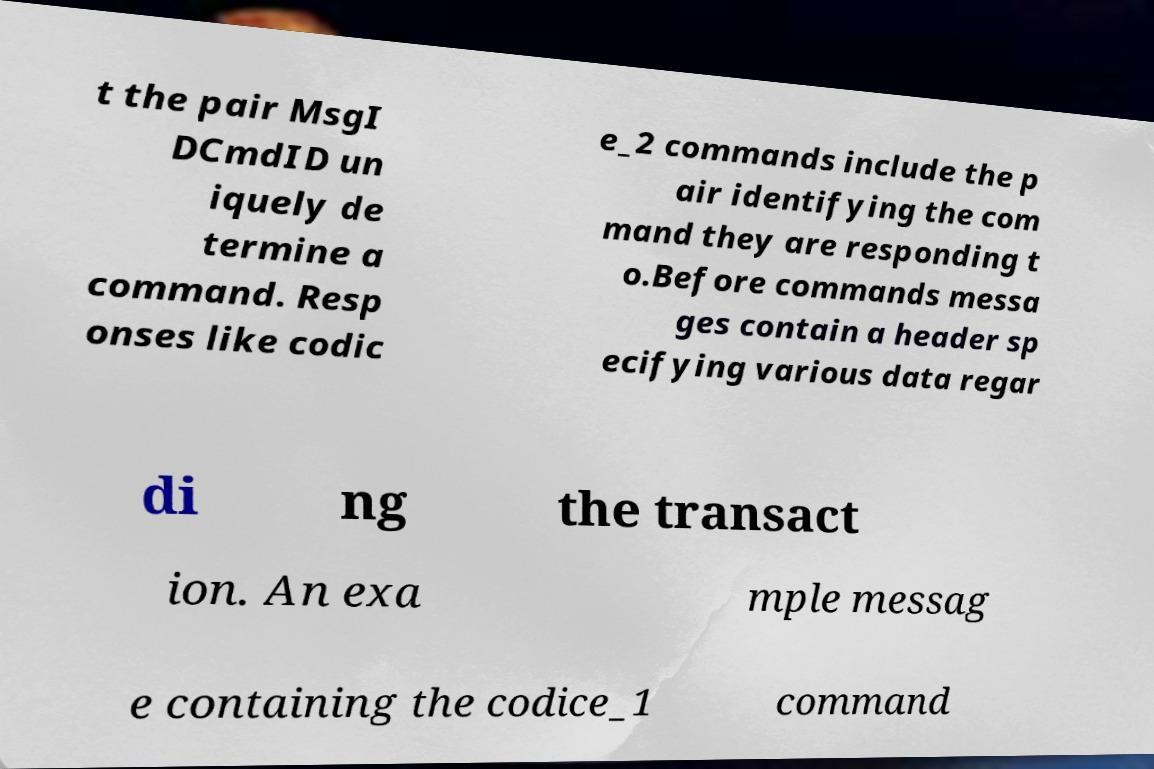I need the written content from this picture converted into text. Can you do that? t the pair MsgI DCmdID un iquely de termine a command. Resp onses like codic e_2 commands include the p air identifying the com mand they are responding t o.Before commands messa ges contain a header sp ecifying various data regar di ng the transact ion. An exa mple messag e containing the codice_1 command 